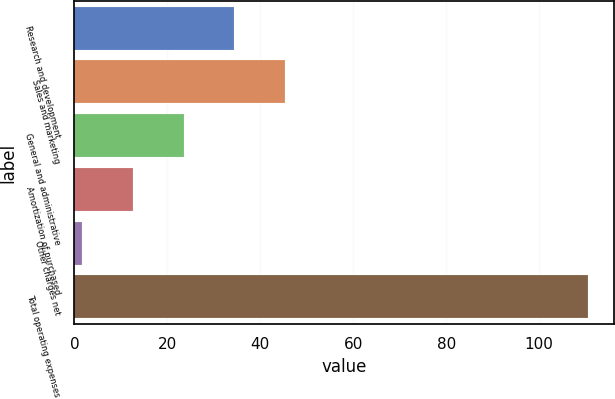Convert chart to OTSL. <chart><loc_0><loc_0><loc_500><loc_500><bar_chart><fcel>Research and development<fcel>Sales and marketing<fcel>General and administrative<fcel>Amortization of purchased<fcel>Other charges net<fcel>Total operating expenses<nl><fcel>34.37<fcel>45.26<fcel>23.48<fcel>12.59<fcel>1.7<fcel>110.6<nl></chart> 